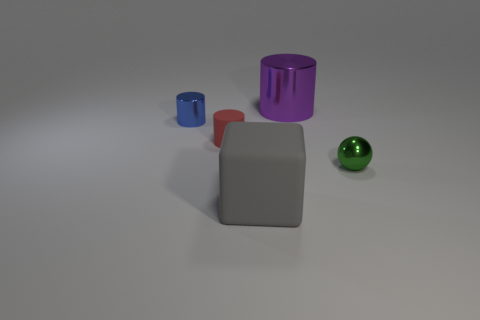Are there an equal number of small green metal spheres on the right side of the tiny blue metallic cylinder and tiny red metallic cubes?
Your answer should be compact. No. How many objects are metallic things that are on the right side of the tiny red matte cylinder or gray blocks?
Provide a succinct answer. 3. What shape is the object that is to the right of the gray matte cube and in front of the purple metallic cylinder?
Your answer should be very brief. Sphere. How many things are either small metal objects behind the tiny green object or objects that are in front of the green metal object?
Give a very brief answer. 2. What number of other things are the same size as the gray matte object?
Give a very brief answer. 1. There is a thing that is behind the shiny sphere and to the right of the tiny red rubber cylinder; how big is it?
Keep it short and to the point. Large. How many large things are purple cylinders or blue metallic things?
Provide a succinct answer. 1. What shape is the tiny shiny thing behind the green sphere?
Offer a very short reply. Cylinder. What number of gray matte things are there?
Give a very brief answer. 1. Does the tiny blue thing have the same material as the large purple cylinder?
Your response must be concise. Yes. 